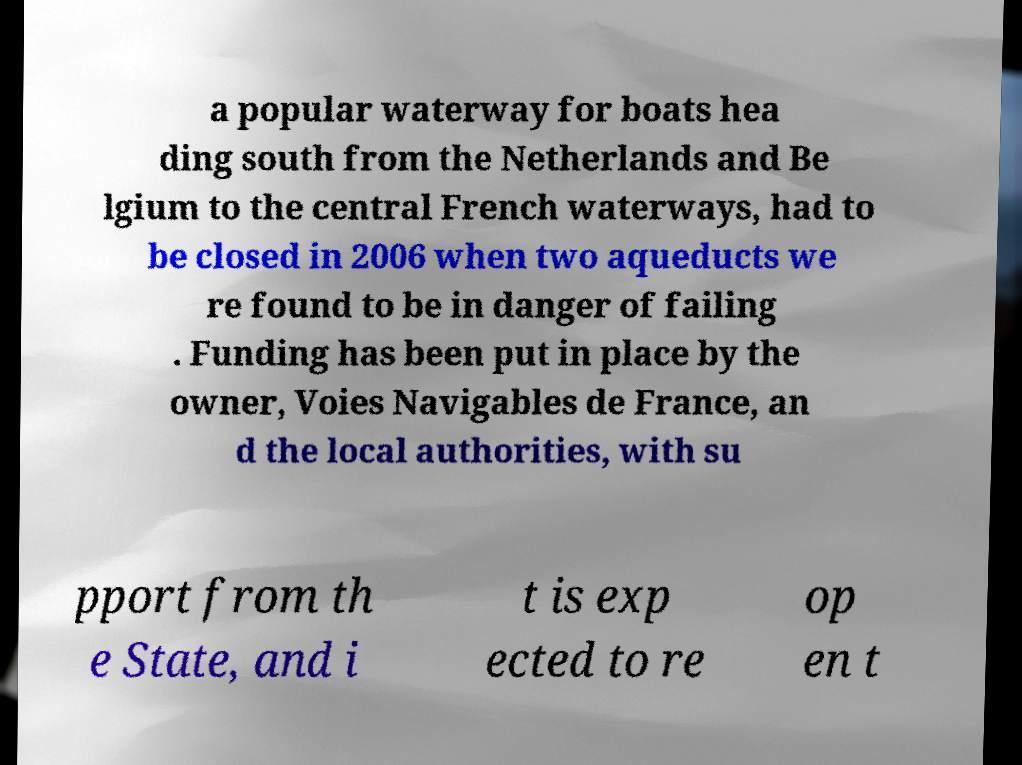Could you assist in decoding the text presented in this image and type it out clearly? a popular waterway for boats hea ding south from the Netherlands and Be lgium to the central French waterways, had to be closed in 2006 when two aqueducts we re found to be in danger of failing . Funding has been put in place by the owner, Voies Navigables de France, an d the local authorities, with su pport from th e State, and i t is exp ected to re op en t 